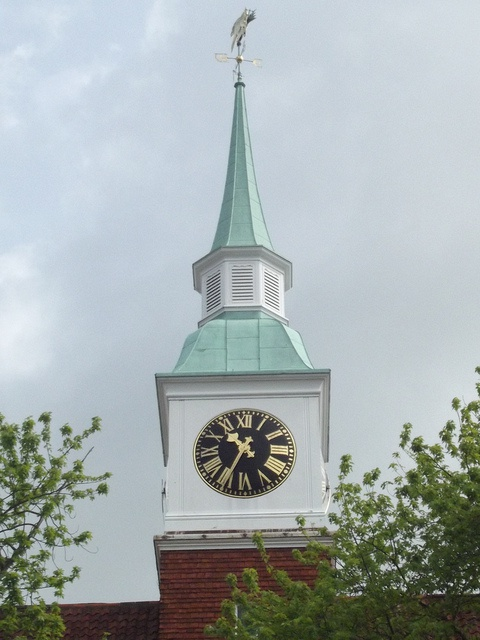Describe the objects in this image and their specific colors. I can see a clock in lightgray, black, gray, and darkgray tones in this image. 